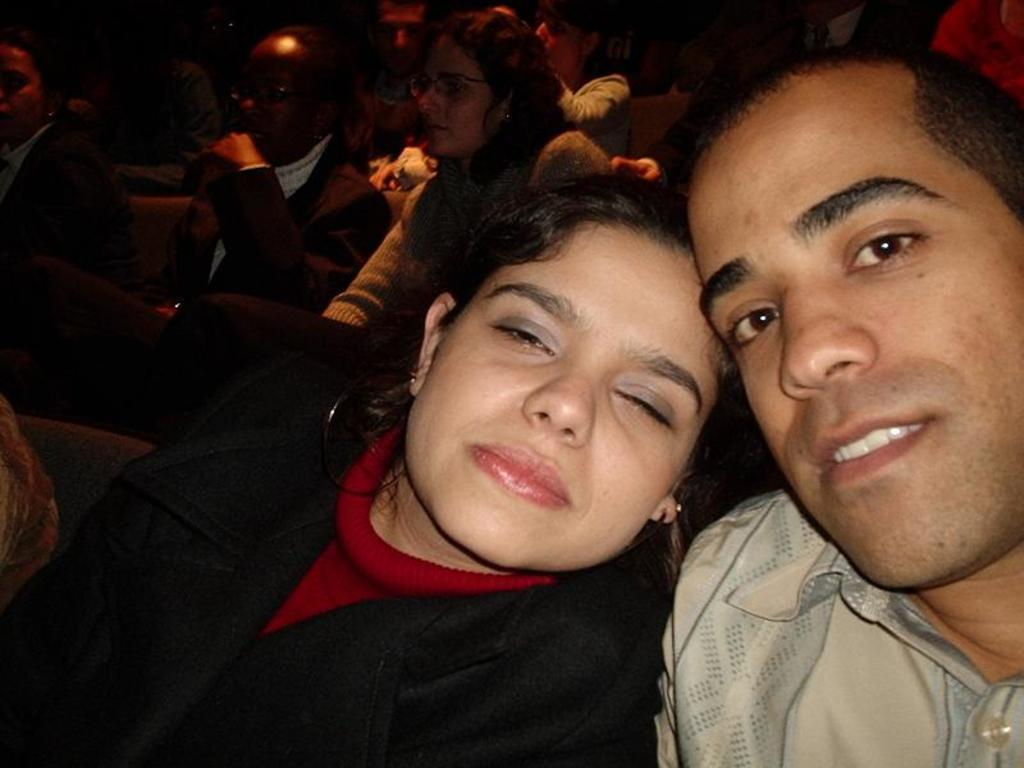What is the relationship between the man and the woman in the image? The provided facts do not specify the relationship between the man and the woman. What is the woman doing in the image? The woman is closing her eyes in the image. Are there any other people present in the image? Yes, there are other people sitting behind the man and the woman in the image. What type of credit card is the man holding in the image? There is no credit card visible in the image. Can you tell me how many yams are on the table in the image? There is no table or yams present in the image. 